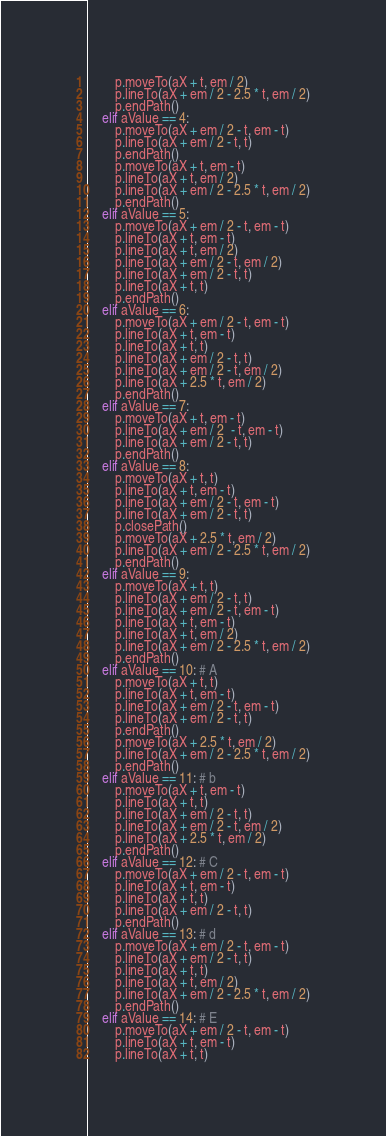Convert code to text. <code><loc_0><loc_0><loc_500><loc_500><_Python_>        p.moveTo(aX + t, em / 2)
        p.lineTo(aX + em / 2 - 2.5 * t, em / 2)
        p.endPath()
    elif aValue == 4:
        p.moveTo(aX + em / 2 - t, em - t)
        p.lineTo(aX + em / 2 - t, t)
        p.endPath()
        p.moveTo(aX + t, em - t)
        p.lineTo(aX + t, em / 2)
        p.lineTo(aX + em / 2 - 2.5 * t, em / 2)
        p.endPath()
    elif aValue == 5:
        p.moveTo(aX + em / 2 - t, em - t)
        p.lineTo(aX + t, em - t)
        p.lineTo(aX + t, em / 2)
        p.lineTo(aX + em / 2 - t, em / 2)
        p.lineTo(aX + em / 2 - t, t)
        p.lineTo(aX + t, t)
        p.endPath()
    elif aValue == 6:
        p.moveTo(aX + em / 2 - t, em - t)
        p.lineTo(aX + t, em - t)
        p.lineTo(aX + t, t)
        p.lineTo(aX + em / 2 - t, t)
        p.lineTo(aX + em / 2 - t, em / 2)
        p.lineTo(aX + 2.5 * t, em / 2)
        p.endPath()
    elif aValue == 7:
        p.moveTo(aX + t, em - t)
        p.lineTo(aX + em / 2  - t, em - t)
        p.lineTo(aX + em / 2 - t, t)
        p.endPath()
    elif aValue == 8:
        p.moveTo(aX + t, t)
        p.lineTo(aX + t, em - t)
        p.lineTo(aX + em / 2 - t, em - t)
        p.lineTo(aX + em / 2 - t, t)
        p.closePath()
        p.moveTo(aX + 2.5 * t, em / 2)
        p.lineTo(aX + em / 2 - 2.5 * t, em / 2)
        p.endPath()
    elif aValue == 9:
        p.moveTo(aX + t, t)
        p.lineTo(aX + em / 2 - t, t)
        p.lineTo(aX + em / 2 - t, em - t)
        p.lineTo(aX + t, em - t)
        p.lineTo(aX + t, em / 2)
        p.lineTo(aX + em / 2 - 2.5 * t, em / 2)
        p.endPath()
    elif aValue == 10: # A
        p.moveTo(aX + t, t)
        p.lineTo(aX + t, em - t)
        p.lineTo(aX + em / 2 - t, em - t)
        p.lineTo(aX + em / 2 - t, t)
        p.endPath()
        p.moveTo(aX + 2.5 * t, em / 2)
        p.lineTo(aX + em / 2 - 2.5 * t, em / 2)
        p.endPath()
    elif aValue == 11: # b
        p.moveTo(aX + t, em - t)
        p.lineTo(aX + t, t)
        p.lineTo(aX + em / 2 - t, t)
        p.lineTo(aX + em / 2 - t, em / 2)
        p.lineTo(aX + 2.5 * t, em / 2)
        p.endPath()
    elif aValue == 12: # C
        p.moveTo(aX + em / 2 - t, em - t)
        p.lineTo(aX + t, em - t)
        p.lineTo(aX + t, t)
        p.lineTo(aX + em / 2 - t, t)
        p.endPath()
    elif aValue == 13: # d
        p.moveTo(aX + em / 2 - t, em - t)
        p.lineTo(aX + em / 2 - t, t)
        p.lineTo(aX + t, t)
        p.lineTo(aX + t, em / 2)
        p.lineTo(aX + em / 2 - 2.5 * t, em / 2)
        p.endPath()
    elif aValue == 14: # E
        p.moveTo(aX + em / 2 - t, em - t)
        p.lineTo(aX + t, em - t)
        p.lineTo(aX + t, t)</code> 